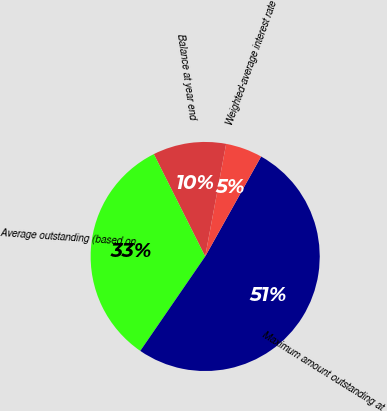Convert chart. <chart><loc_0><loc_0><loc_500><loc_500><pie_chart><fcel>Balance at year end<fcel>Average outstanding (based on<fcel>Maximum amount outstanding at<fcel>Weighted-average interest rate<nl><fcel>10.33%<fcel>33.01%<fcel>51.46%<fcel>5.19%<nl></chart> 